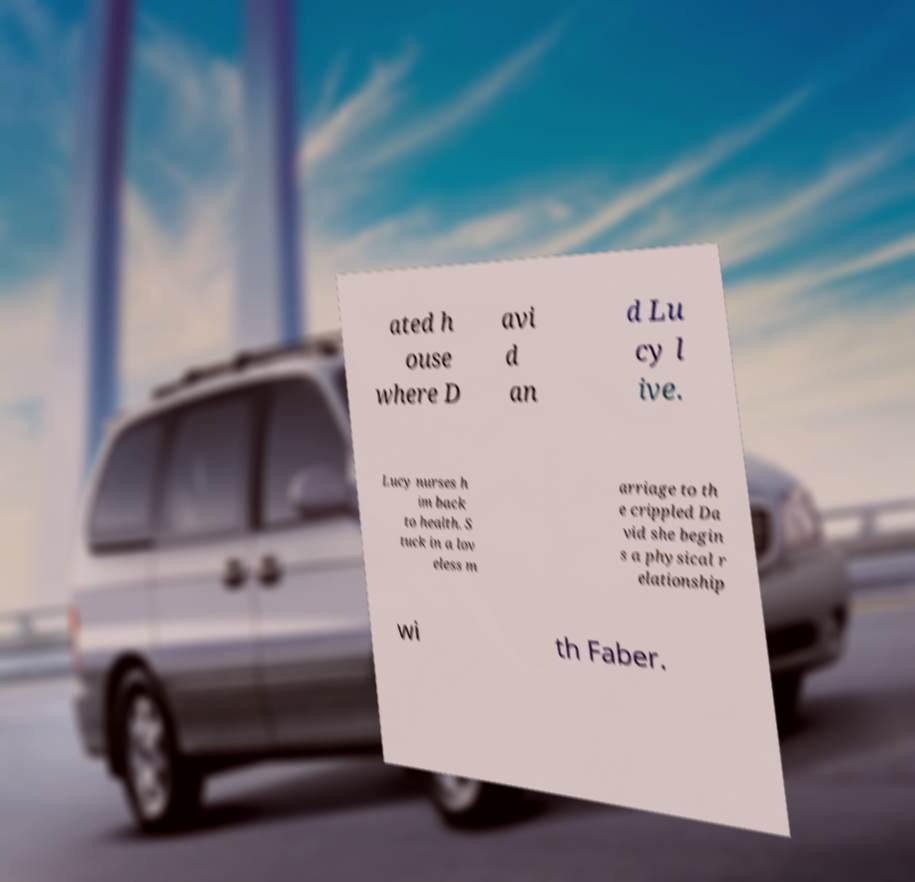There's text embedded in this image that I need extracted. Can you transcribe it verbatim? ated h ouse where D avi d an d Lu cy l ive. Lucy nurses h im back to health. S tuck in a lov eless m arriage to th e crippled Da vid she begin s a physical r elationship wi th Faber. 